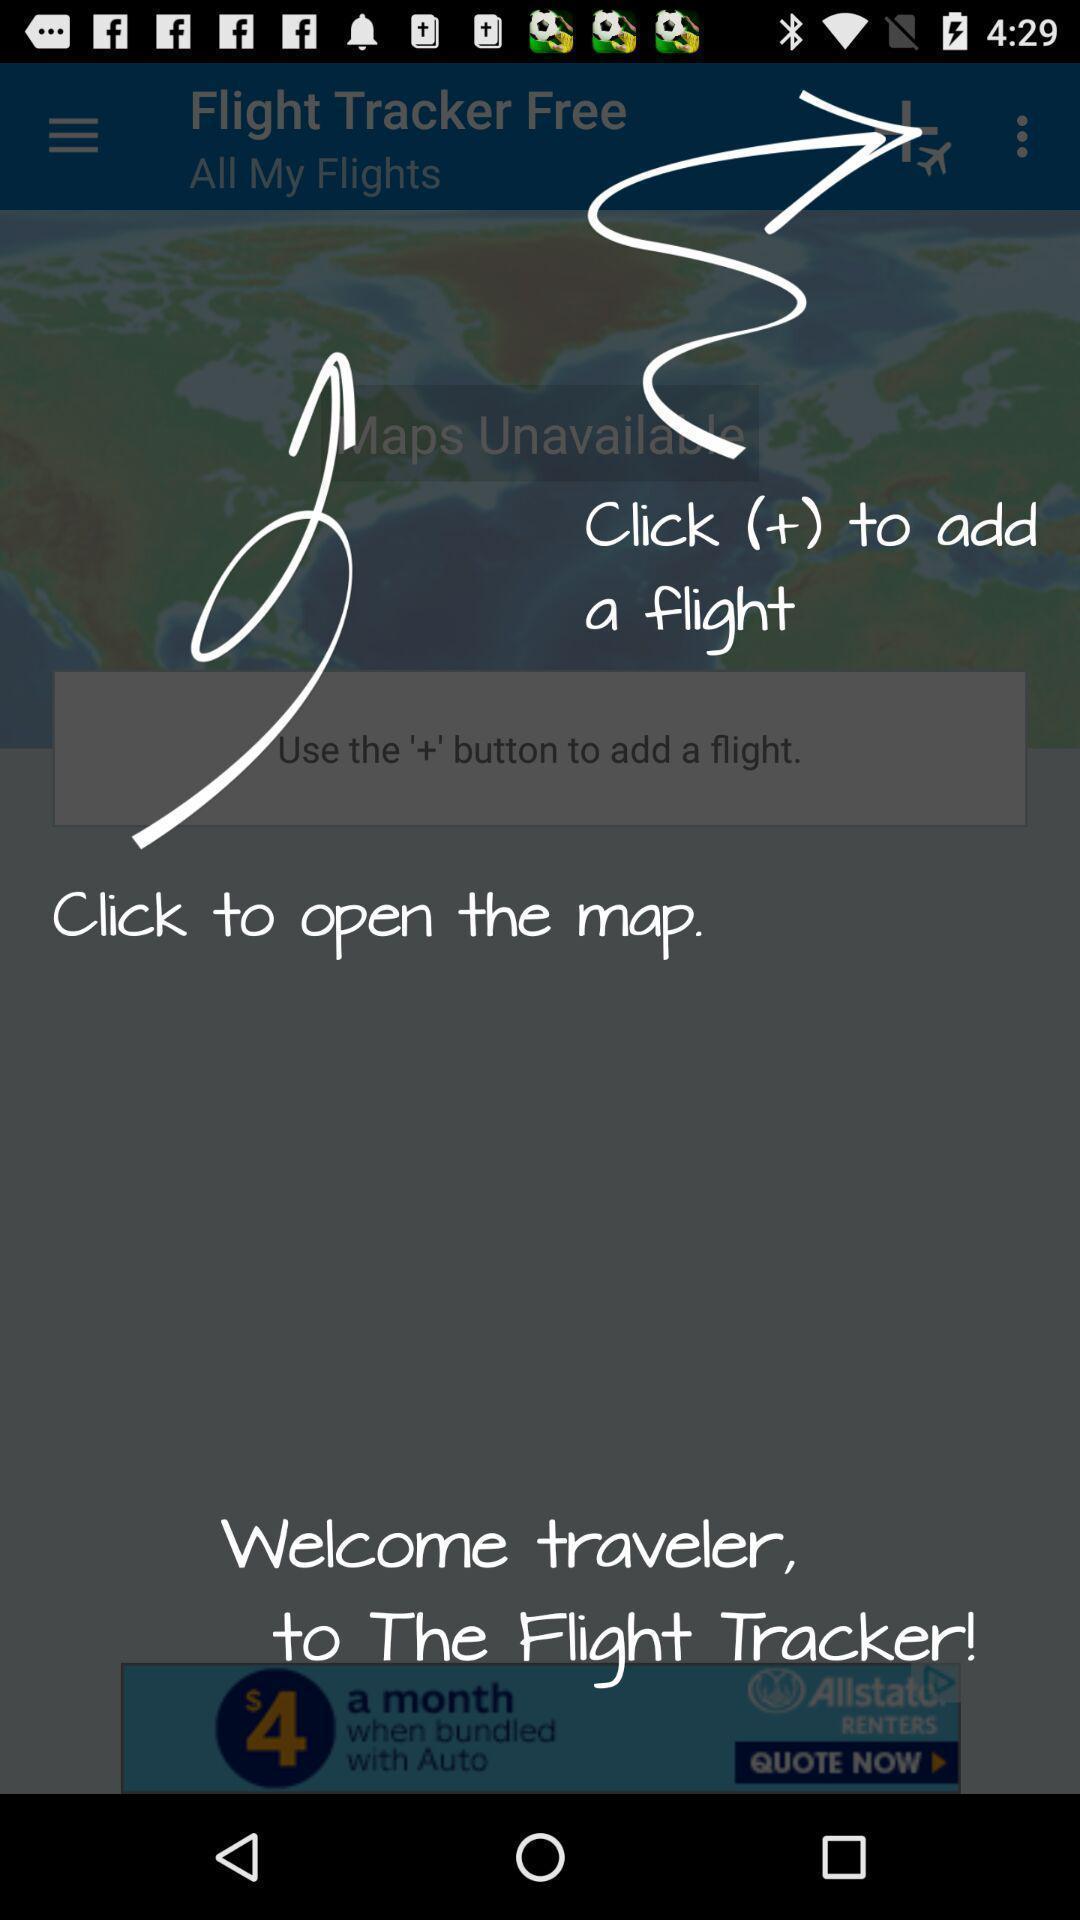Please provide a description for this image. Welcome page. 